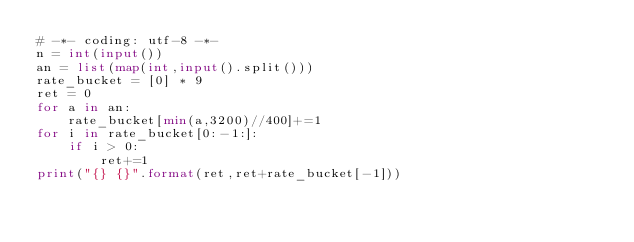Convert code to text. <code><loc_0><loc_0><loc_500><loc_500><_Python_># -*- coding: utf-8 -*-
n = int(input())
an = list(map(int,input().split()))
rate_bucket = [0] * 9
ret = 0
for a in an:
    rate_bucket[min(a,3200)//400]+=1
for i in rate_bucket[0:-1:]:
    if i > 0:
        ret+=1
print("{} {}".format(ret,ret+rate_bucket[-1]))
</code> 